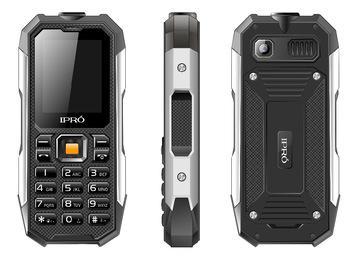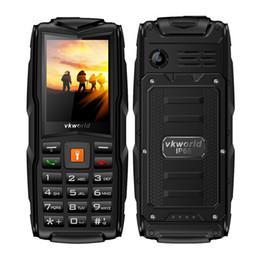The first image is the image on the left, the second image is the image on the right. For the images shown, is this caption "One image features a grenade-look flip phone with a round 'pin' on its side, and the phone is shown flipped open in at least a forward and a side view." true? Answer yes or no. No. The first image is the image on the left, the second image is the image on the right. For the images displayed, is the sentence "One of the phones shows an image of four people in a sunset." factually correct? Answer yes or no. Yes. 